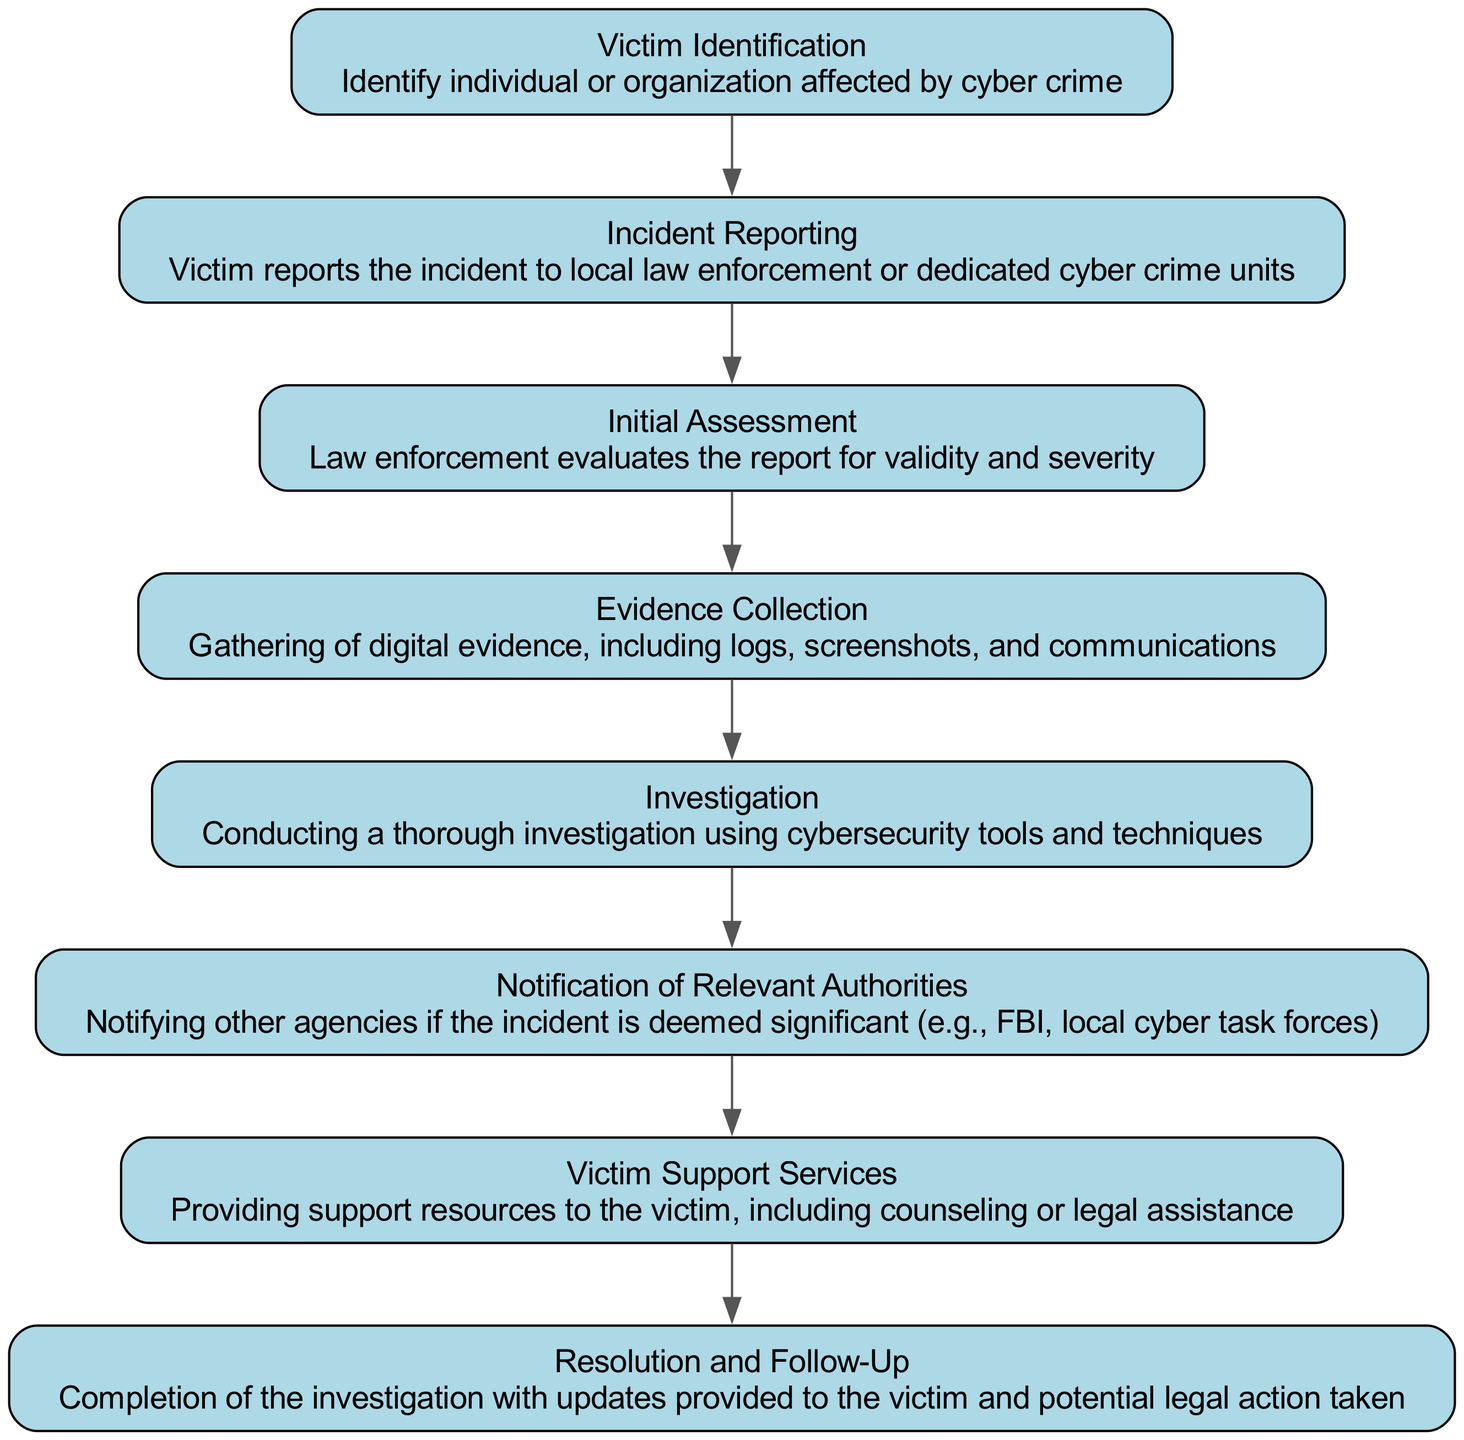What is the first step in the cyber crime reporting process? The first step mentioned in the diagram is "Victim Identification," which identifies the individual or organization affected by cyber crime.
Answer: Victim Identification How many steps are in the cyber crime reporting process? The diagram outlines a total of eight steps in the cyber crime reporting process, as indicated by the nodes present.
Answer: Eight What type of support is provided to victims? The node labeled "Victim Support Services" specifies that support resources, including counseling or legal assistance, are provided to victims.
Answer: Counseling or legal assistance What occurs immediately after the "Incident Reporting" step? According to the flow of the diagram, the step that follows "Incident Reporting" is "Initial Assessment," where law enforcement evaluates the report for validity and severity.
Answer: Initial Assessment Which step involves notifying other agencies? The "Notification of Relevant Authorities" step is specifically where other agencies are notified if the incident is deemed significant.
Answer: Notification of Relevant Authorities What is included in the "Evidence Collection" step? The description for "Evidence Collection" clearly states that this involves gathering digital evidence, including logs, screenshots, and communications.
Answer: Digital evidence What is the last step mentioned in the process? The final step in the flow chart is "Resolution and Follow-Up," which marks the completion of the investigation and provides updates to the victim.
Answer: Resolution and Follow-Up Which step provides support resources to the victim? The "Victim Support Services" step is designated for providing support resources such as counseling and legal assistance to the victim.
Answer: Victim Support Services In which step does a thorough investigation occur? The process outlines that a "thorough investigation" takes place in the "Investigation" step, utilizing cybersecurity tools and techniques.
Answer: Investigation 